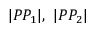<formula> <loc_0><loc_0><loc_500><loc_500>| P P _ { 1 } | , \ | P P _ { 2 } |</formula> 